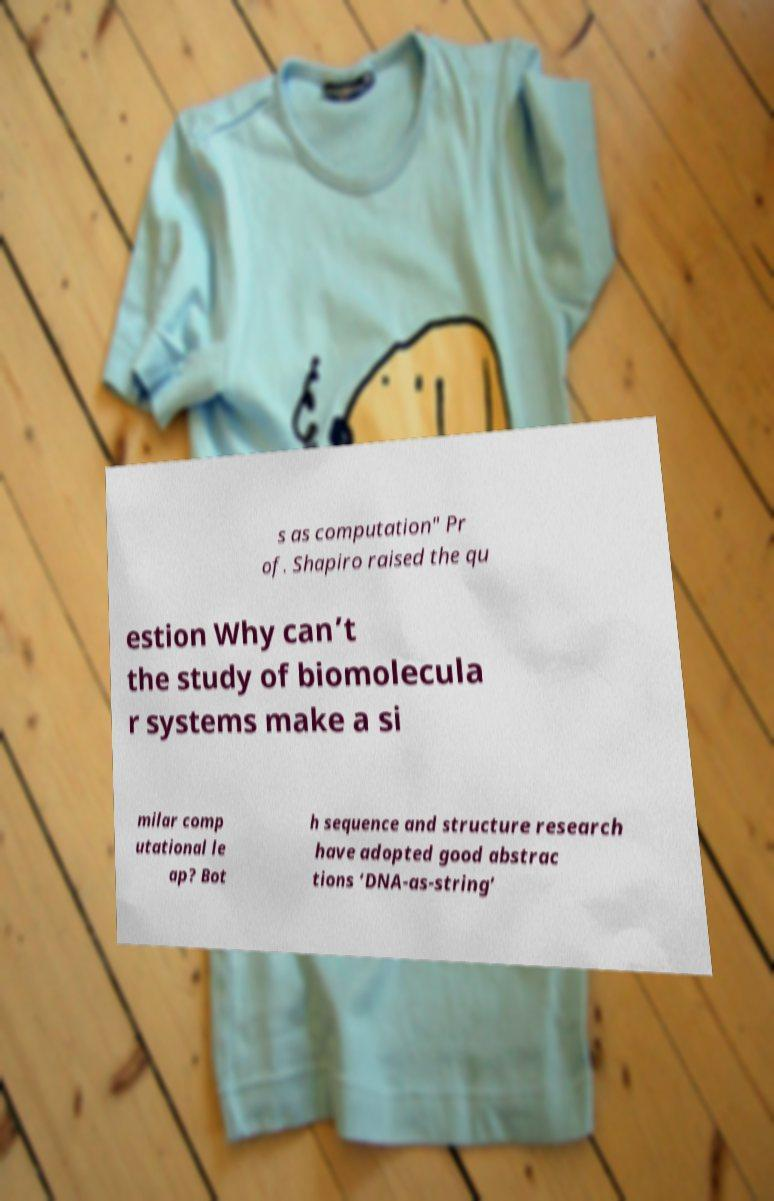Could you extract and type out the text from this image? s as computation" Pr of. Shapiro raised the qu estion Why can’t the study of biomolecula r systems make a si milar comp utational le ap? Bot h sequence and structure research have adopted good abstrac tions ‘DNA-as-string’ 